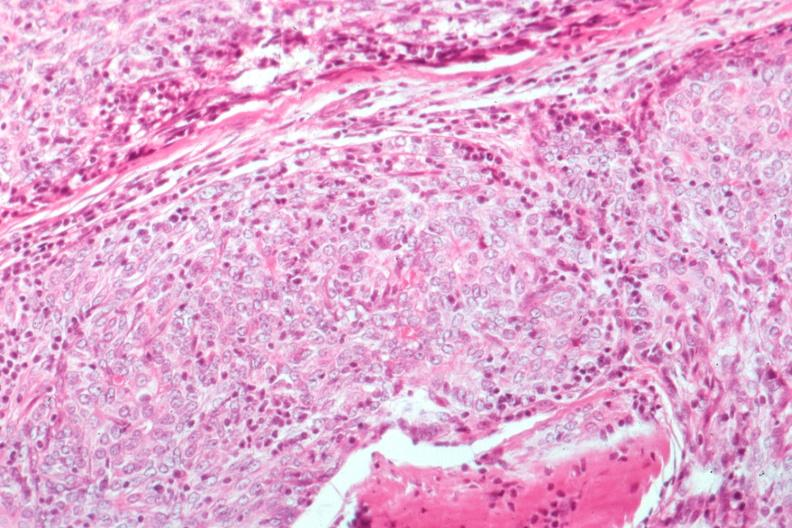s hematologic present?
Answer the question using a single word or phrase. Yes 